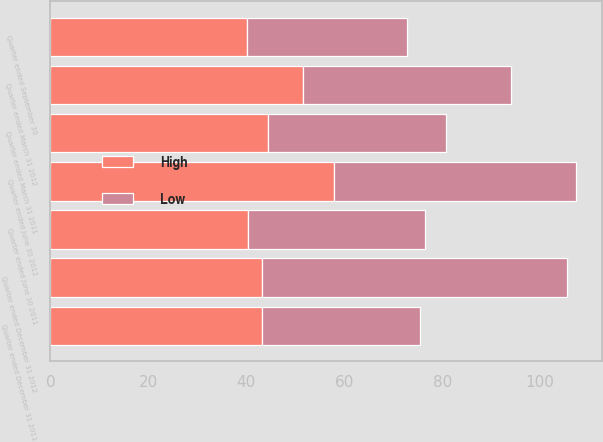<chart> <loc_0><loc_0><loc_500><loc_500><stacked_bar_chart><ecel><fcel>Quarter ended December 31 2012<fcel>Quarter ended September 30<fcel>Quarter ended June 30 2012<fcel>Quarter ended March 31 2012<fcel>Quarter ended December 31 2011<fcel>Quarter ended June 30 2011<fcel>Quarter ended March 31 2011<nl><fcel>High<fcel>43.12<fcel>40.13<fcel>57.88<fcel>51.51<fcel>43.12<fcel>40.35<fcel>44.44<nl><fcel>Low<fcel>62.25<fcel>32.76<fcel>49.37<fcel>42.53<fcel>32.36<fcel>36.1<fcel>36.36<nl></chart> 